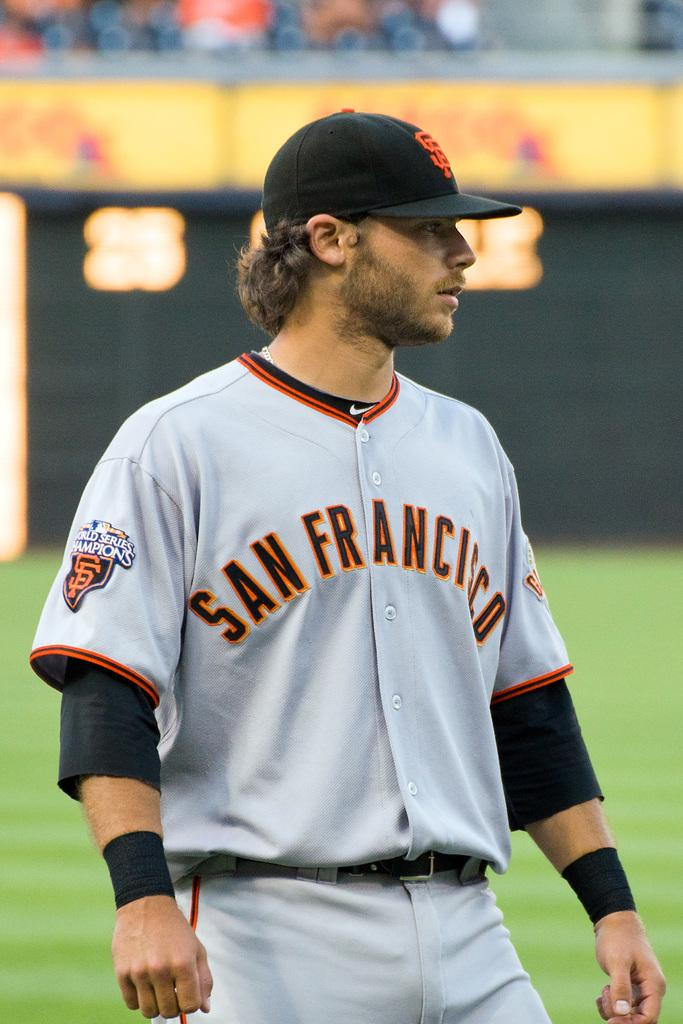<image>
Write a terse but informative summary of the picture. The San Francisco player is standing on the baseball field. 